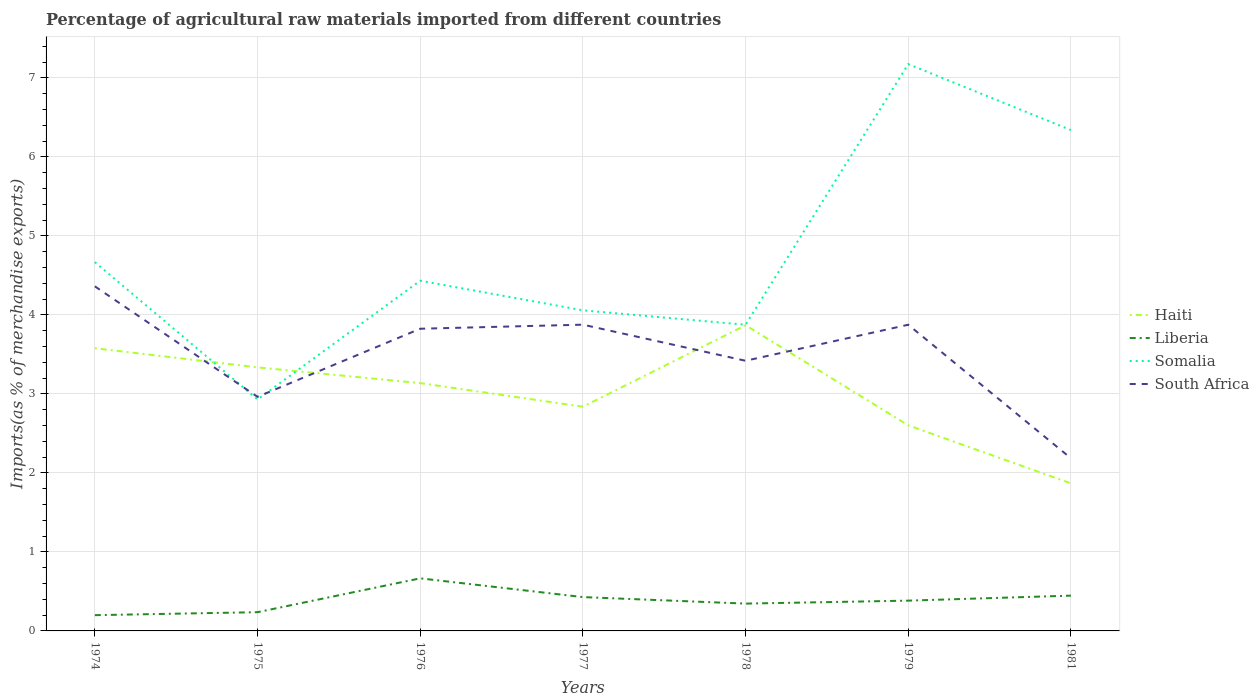How many different coloured lines are there?
Offer a very short reply. 4. Does the line corresponding to Somalia intersect with the line corresponding to Haiti?
Offer a very short reply. Yes. Across all years, what is the maximum percentage of imports to different countries in South Africa?
Make the answer very short. 2.19. In which year was the percentage of imports to different countries in Somalia maximum?
Your answer should be compact. 1975. What is the total percentage of imports to different countries in South Africa in the graph?
Your response must be concise. 1.64. What is the difference between the highest and the second highest percentage of imports to different countries in South Africa?
Make the answer very short. 2.18. Is the percentage of imports to different countries in Haiti strictly greater than the percentage of imports to different countries in Somalia over the years?
Your answer should be compact. No. How many lines are there?
Ensure brevity in your answer.  4. What is the difference between two consecutive major ticks on the Y-axis?
Provide a short and direct response. 1. Does the graph contain any zero values?
Your response must be concise. No. Does the graph contain grids?
Keep it short and to the point. Yes. Where does the legend appear in the graph?
Your response must be concise. Center right. What is the title of the graph?
Provide a succinct answer. Percentage of agricultural raw materials imported from different countries. What is the label or title of the Y-axis?
Give a very brief answer. Imports(as % of merchandise exports). What is the Imports(as % of merchandise exports) of Haiti in 1974?
Give a very brief answer. 3.58. What is the Imports(as % of merchandise exports) in Liberia in 1974?
Keep it short and to the point. 0.2. What is the Imports(as % of merchandise exports) of Somalia in 1974?
Offer a very short reply. 4.67. What is the Imports(as % of merchandise exports) in South Africa in 1974?
Provide a short and direct response. 4.36. What is the Imports(as % of merchandise exports) in Haiti in 1975?
Keep it short and to the point. 3.34. What is the Imports(as % of merchandise exports) in Liberia in 1975?
Your answer should be compact. 0.24. What is the Imports(as % of merchandise exports) of Somalia in 1975?
Your answer should be compact. 2.93. What is the Imports(as % of merchandise exports) in South Africa in 1975?
Offer a very short reply. 2.96. What is the Imports(as % of merchandise exports) of Haiti in 1976?
Keep it short and to the point. 3.14. What is the Imports(as % of merchandise exports) of Liberia in 1976?
Give a very brief answer. 0.67. What is the Imports(as % of merchandise exports) of Somalia in 1976?
Make the answer very short. 4.43. What is the Imports(as % of merchandise exports) in South Africa in 1976?
Provide a short and direct response. 3.82. What is the Imports(as % of merchandise exports) of Haiti in 1977?
Provide a succinct answer. 2.84. What is the Imports(as % of merchandise exports) in Liberia in 1977?
Make the answer very short. 0.43. What is the Imports(as % of merchandise exports) in Somalia in 1977?
Make the answer very short. 4.06. What is the Imports(as % of merchandise exports) in South Africa in 1977?
Provide a succinct answer. 3.88. What is the Imports(as % of merchandise exports) of Haiti in 1978?
Make the answer very short. 3.87. What is the Imports(as % of merchandise exports) in Liberia in 1978?
Your answer should be very brief. 0.35. What is the Imports(as % of merchandise exports) of Somalia in 1978?
Make the answer very short. 3.88. What is the Imports(as % of merchandise exports) in South Africa in 1978?
Your answer should be very brief. 3.42. What is the Imports(as % of merchandise exports) of Haiti in 1979?
Your answer should be very brief. 2.6. What is the Imports(as % of merchandise exports) of Liberia in 1979?
Provide a short and direct response. 0.38. What is the Imports(as % of merchandise exports) in Somalia in 1979?
Provide a short and direct response. 7.17. What is the Imports(as % of merchandise exports) in South Africa in 1979?
Offer a terse response. 3.88. What is the Imports(as % of merchandise exports) in Haiti in 1981?
Offer a terse response. 1.87. What is the Imports(as % of merchandise exports) of Liberia in 1981?
Offer a very short reply. 0.45. What is the Imports(as % of merchandise exports) in Somalia in 1981?
Your answer should be compact. 6.34. What is the Imports(as % of merchandise exports) in South Africa in 1981?
Keep it short and to the point. 2.19. Across all years, what is the maximum Imports(as % of merchandise exports) in Haiti?
Offer a very short reply. 3.87. Across all years, what is the maximum Imports(as % of merchandise exports) of Liberia?
Keep it short and to the point. 0.67. Across all years, what is the maximum Imports(as % of merchandise exports) of Somalia?
Provide a succinct answer. 7.17. Across all years, what is the maximum Imports(as % of merchandise exports) in South Africa?
Make the answer very short. 4.36. Across all years, what is the minimum Imports(as % of merchandise exports) in Haiti?
Provide a succinct answer. 1.87. Across all years, what is the minimum Imports(as % of merchandise exports) of Liberia?
Give a very brief answer. 0.2. Across all years, what is the minimum Imports(as % of merchandise exports) of Somalia?
Your answer should be compact. 2.93. Across all years, what is the minimum Imports(as % of merchandise exports) of South Africa?
Ensure brevity in your answer.  2.19. What is the total Imports(as % of merchandise exports) of Haiti in the graph?
Offer a terse response. 21.23. What is the total Imports(as % of merchandise exports) in Liberia in the graph?
Offer a terse response. 2.71. What is the total Imports(as % of merchandise exports) of Somalia in the graph?
Make the answer very short. 33.48. What is the total Imports(as % of merchandise exports) of South Africa in the graph?
Ensure brevity in your answer.  24.51. What is the difference between the Imports(as % of merchandise exports) of Haiti in 1974 and that in 1975?
Offer a terse response. 0.24. What is the difference between the Imports(as % of merchandise exports) in Liberia in 1974 and that in 1975?
Your response must be concise. -0.04. What is the difference between the Imports(as % of merchandise exports) of Somalia in 1974 and that in 1975?
Your response must be concise. 1.74. What is the difference between the Imports(as % of merchandise exports) in South Africa in 1974 and that in 1975?
Ensure brevity in your answer.  1.4. What is the difference between the Imports(as % of merchandise exports) of Haiti in 1974 and that in 1976?
Give a very brief answer. 0.44. What is the difference between the Imports(as % of merchandise exports) of Liberia in 1974 and that in 1976?
Your answer should be very brief. -0.47. What is the difference between the Imports(as % of merchandise exports) in Somalia in 1974 and that in 1976?
Keep it short and to the point. 0.24. What is the difference between the Imports(as % of merchandise exports) in South Africa in 1974 and that in 1976?
Provide a succinct answer. 0.54. What is the difference between the Imports(as % of merchandise exports) in Haiti in 1974 and that in 1977?
Make the answer very short. 0.74. What is the difference between the Imports(as % of merchandise exports) of Liberia in 1974 and that in 1977?
Your response must be concise. -0.23. What is the difference between the Imports(as % of merchandise exports) in Somalia in 1974 and that in 1977?
Your response must be concise. 0.61. What is the difference between the Imports(as % of merchandise exports) of South Africa in 1974 and that in 1977?
Your answer should be compact. 0.49. What is the difference between the Imports(as % of merchandise exports) in Haiti in 1974 and that in 1978?
Keep it short and to the point. -0.29. What is the difference between the Imports(as % of merchandise exports) in Liberia in 1974 and that in 1978?
Ensure brevity in your answer.  -0.15. What is the difference between the Imports(as % of merchandise exports) in Somalia in 1974 and that in 1978?
Provide a short and direct response. 0.79. What is the difference between the Imports(as % of merchandise exports) of South Africa in 1974 and that in 1978?
Give a very brief answer. 0.94. What is the difference between the Imports(as % of merchandise exports) in Haiti in 1974 and that in 1979?
Offer a terse response. 0.98. What is the difference between the Imports(as % of merchandise exports) of Liberia in 1974 and that in 1979?
Your answer should be compact. -0.18. What is the difference between the Imports(as % of merchandise exports) of Somalia in 1974 and that in 1979?
Your answer should be compact. -2.51. What is the difference between the Imports(as % of merchandise exports) in South Africa in 1974 and that in 1979?
Your response must be concise. 0.49. What is the difference between the Imports(as % of merchandise exports) in Haiti in 1974 and that in 1981?
Ensure brevity in your answer.  1.71. What is the difference between the Imports(as % of merchandise exports) in Liberia in 1974 and that in 1981?
Provide a short and direct response. -0.25. What is the difference between the Imports(as % of merchandise exports) of Somalia in 1974 and that in 1981?
Provide a short and direct response. -1.67. What is the difference between the Imports(as % of merchandise exports) of South Africa in 1974 and that in 1981?
Give a very brief answer. 2.18. What is the difference between the Imports(as % of merchandise exports) of Haiti in 1975 and that in 1976?
Offer a very short reply. 0.2. What is the difference between the Imports(as % of merchandise exports) of Liberia in 1975 and that in 1976?
Provide a succinct answer. -0.43. What is the difference between the Imports(as % of merchandise exports) of Somalia in 1975 and that in 1976?
Provide a short and direct response. -1.5. What is the difference between the Imports(as % of merchandise exports) in South Africa in 1975 and that in 1976?
Keep it short and to the point. -0.86. What is the difference between the Imports(as % of merchandise exports) in Haiti in 1975 and that in 1977?
Make the answer very short. 0.5. What is the difference between the Imports(as % of merchandise exports) of Liberia in 1975 and that in 1977?
Your answer should be compact. -0.19. What is the difference between the Imports(as % of merchandise exports) of Somalia in 1975 and that in 1977?
Ensure brevity in your answer.  -1.13. What is the difference between the Imports(as % of merchandise exports) of South Africa in 1975 and that in 1977?
Your response must be concise. -0.91. What is the difference between the Imports(as % of merchandise exports) of Haiti in 1975 and that in 1978?
Provide a succinct answer. -0.53. What is the difference between the Imports(as % of merchandise exports) in Liberia in 1975 and that in 1978?
Provide a short and direct response. -0.11. What is the difference between the Imports(as % of merchandise exports) of Somalia in 1975 and that in 1978?
Give a very brief answer. -0.95. What is the difference between the Imports(as % of merchandise exports) of South Africa in 1975 and that in 1978?
Provide a succinct answer. -0.46. What is the difference between the Imports(as % of merchandise exports) in Haiti in 1975 and that in 1979?
Keep it short and to the point. 0.73. What is the difference between the Imports(as % of merchandise exports) in Liberia in 1975 and that in 1979?
Your answer should be compact. -0.15. What is the difference between the Imports(as % of merchandise exports) in Somalia in 1975 and that in 1979?
Your answer should be very brief. -4.24. What is the difference between the Imports(as % of merchandise exports) in South Africa in 1975 and that in 1979?
Offer a terse response. -0.91. What is the difference between the Imports(as % of merchandise exports) in Haiti in 1975 and that in 1981?
Ensure brevity in your answer.  1.47. What is the difference between the Imports(as % of merchandise exports) in Liberia in 1975 and that in 1981?
Provide a succinct answer. -0.21. What is the difference between the Imports(as % of merchandise exports) in Somalia in 1975 and that in 1981?
Your answer should be compact. -3.41. What is the difference between the Imports(as % of merchandise exports) in South Africa in 1975 and that in 1981?
Provide a succinct answer. 0.78. What is the difference between the Imports(as % of merchandise exports) in Haiti in 1976 and that in 1977?
Provide a short and direct response. 0.3. What is the difference between the Imports(as % of merchandise exports) of Liberia in 1976 and that in 1977?
Offer a terse response. 0.24. What is the difference between the Imports(as % of merchandise exports) of Somalia in 1976 and that in 1977?
Your answer should be compact. 0.37. What is the difference between the Imports(as % of merchandise exports) in South Africa in 1976 and that in 1977?
Make the answer very short. -0.05. What is the difference between the Imports(as % of merchandise exports) of Haiti in 1976 and that in 1978?
Provide a succinct answer. -0.73. What is the difference between the Imports(as % of merchandise exports) of Liberia in 1976 and that in 1978?
Ensure brevity in your answer.  0.32. What is the difference between the Imports(as % of merchandise exports) of Somalia in 1976 and that in 1978?
Your answer should be very brief. 0.56. What is the difference between the Imports(as % of merchandise exports) of South Africa in 1976 and that in 1978?
Give a very brief answer. 0.41. What is the difference between the Imports(as % of merchandise exports) in Haiti in 1976 and that in 1979?
Offer a very short reply. 0.53. What is the difference between the Imports(as % of merchandise exports) of Liberia in 1976 and that in 1979?
Provide a short and direct response. 0.28. What is the difference between the Imports(as % of merchandise exports) in Somalia in 1976 and that in 1979?
Offer a terse response. -2.74. What is the difference between the Imports(as % of merchandise exports) of South Africa in 1976 and that in 1979?
Provide a succinct answer. -0.05. What is the difference between the Imports(as % of merchandise exports) of Haiti in 1976 and that in 1981?
Provide a succinct answer. 1.27. What is the difference between the Imports(as % of merchandise exports) in Liberia in 1976 and that in 1981?
Provide a short and direct response. 0.22. What is the difference between the Imports(as % of merchandise exports) in Somalia in 1976 and that in 1981?
Your answer should be very brief. -1.91. What is the difference between the Imports(as % of merchandise exports) in South Africa in 1976 and that in 1981?
Your response must be concise. 1.64. What is the difference between the Imports(as % of merchandise exports) of Haiti in 1977 and that in 1978?
Keep it short and to the point. -1.03. What is the difference between the Imports(as % of merchandise exports) of Liberia in 1977 and that in 1978?
Make the answer very short. 0.08. What is the difference between the Imports(as % of merchandise exports) of Somalia in 1977 and that in 1978?
Offer a terse response. 0.18. What is the difference between the Imports(as % of merchandise exports) in South Africa in 1977 and that in 1978?
Give a very brief answer. 0.46. What is the difference between the Imports(as % of merchandise exports) of Haiti in 1977 and that in 1979?
Your answer should be compact. 0.24. What is the difference between the Imports(as % of merchandise exports) in Liberia in 1977 and that in 1979?
Make the answer very short. 0.04. What is the difference between the Imports(as % of merchandise exports) of Somalia in 1977 and that in 1979?
Give a very brief answer. -3.12. What is the difference between the Imports(as % of merchandise exports) in South Africa in 1977 and that in 1979?
Ensure brevity in your answer.  0. What is the difference between the Imports(as % of merchandise exports) of Haiti in 1977 and that in 1981?
Offer a very short reply. 0.97. What is the difference between the Imports(as % of merchandise exports) in Liberia in 1977 and that in 1981?
Give a very brief answer. -0.02. What is the difference between the Imports(as % of merchandise exports) in Somalia in 1977 and that in 1981?
Your answer should be very brief. -2.28. What is the difference between the Imports(as % of merchandise exports) in South Africa in 1977 and that in 1981?
Your response must be concise. 1.69. What is the difference between the Imports(as % of merchandise exports) of Haiti in 1978 and that in 1979?
Keep it short and to the point. 1.27. What is the difference between the Imports(as % of merchandise exports) of Liberia in 1978 and that in 1979?
Ensure brevity in your answer.  -0.04. What is the difference between the Imports(as % of merchandise exports) of Somalia in 1978 and that in 1979?
Keep it short and to the point. -3.3. What is the difference between the Imports(as % of merchandise exports) of South Africa in 1978 and that in 1979?
Give a very brief answer. -0.46. What is the difference between the Imports(as % of merchandise exports) in Haiti in 1978 and that in 1981?
Make the answer very short. 2. What is the difference between the Imports(as % of merchandise exports) of Liberia in 1978 and that in 1981?
Your response must be concise. -0.1. What is the difference between the Imports(as % of merchandise exports) of Somalia in 1978 and that in 1981?
Your answer should be compact. -2.46. What is the difference between the Imports(as % of merchandise exports) in South Africa in 1978 and that in 1981?
Your response must be concise. 1.23. What is the difference between the Imports(as % of merchandise exports) in Haiti in 1979 and that in 1981?
Offer a terse response. 0.73. What is the difference between the Imports(as % of merchandise exports) of Liberia in 1979 and that in 1981?
Keep it short and to the point. -0.06. What is the difference between the Imports(as % of merchandise exports) of Somalia in 1979 and that in 1981?
Your response must be concise. 0.83. What is the difference between the Imports(as % of merchandise exports) in South Africa in 1979 and that in 1981?
Ensure brevity in your answer.  1.69. What is the difference between the Imports(as % of merchandise exports) in Haiti in 1974 and the Imports(as % of merchandise exports) in Liberia in 1975?
Ensure brevity in your answer.  3.34. What is the difference between the Imports(as % of merchandise exports) in Haiti in 1974 and the Imports(as % of merchandise exports) in Somalia in 1975?
Your answer should be very brief. 0.65. What is the difference between the Imports(as % of merchandise exports) in Haiti in 1974 and the Imports(as % of merchandise exports) in South Africa in 1975?
Your answer should be compact. 0.61. What is the difference between the Imports(as % of merchandise exports) of Liberia in 1974 and the Imports(as % of merchandise exports) of Somalia in 1975?
Provide a short and direct response. -2.73. What is the difference between the Imports(as % of merchandise exports) of Liberia in 1974 and the Imports(as % of merchandise exports) of South Africa in 1975?
Offer a terse response. -2.76. What is the difference between the Imports(as % of merchandise exports) in Somalia in 1974 and the Imports(as % of merchandise exports) in South Africa in 1975?
Ensure brevity in your answer.  1.71. What is the difference between the Imports(as % of merchandise exports) in Haiti in 1974 and the Imports(as % of merchandise exports) in Liberia in 1976?
Your answer should be very brief. 2.91. What is the difference between the Imports(as % of merchandise exports) in Haiti in 1974 and the Imports(as % of merchandise exports) in Somalia in 1976?
Provide a short and direct response. -0.85. What is the difference between the Imports(as % of merchandise exports) of Haiti in 1974 and the Imports(as % of merchandise exports) of South Africa in 1976?
Make the answer very short. -0.25. What is the difference between the Imports(as % of merchandise exports) in Liberia in 1974 and the Imports(as % of merchandise exports) in Somalia in 1976?
Provide a succinct answer. -4.23. What is the difference between the Imports(as % of merchandise exports) in Liberia in 1974 and the Imports(as % of merchandise exports) in South Africa in 1976?
Keep it short and to the point. -3.63. What is the difference between the Imports(as % of merchandise exports) of Somalia in 1974 and the Imports(as % of merchandise exports) of South Africa in 1976?
Provide a short and direct response. 0.84. What is the difference between the Imports(as % of merchandise exports) of Haiti in 1974 and the Imports(as % of merchandise exports) of Liberia in 1977?
Offer a very short reply. 3.15. What is the difference between the Imports(as % of merchandise exports) of Haiti in 1974 and the Imports(as % of merchandise exports) of Somalia in 1977?
Your answer should be compact. -0.48. What is the difference between the Imports(as % of merchandise exports) of Haiti in 1974 and the Imports(as % of merchandise exports) of South Africa in 1977?
Ensure brevity in your answer.  -0.3. What is the difference between the Imports(as % of merchandise exports) of Liberia in 1974 and the Imports(as % of merchandise exports) of Somalia in 1977?
Offer a terse response. -3.86. What is the difference between the Imports(as % of merchandise exports) of Liberia in 1974 and the Imports(as % of merchandise exports) of South Africa in 1977?
Make the answer very short. -3.68. What is the difference between the Imports(as % of merchandise exports) in Somalia in 1974 and the Imports(as % of merchandise exports) in South Africa in 1977?
Ensure brevity in your answer.  0.79. What is the difference between the Imports(as % of merchandise exports) in Haiti in 1974 and the Imports(as % of merchandise exports) in Liberia in 1978?
Your answer should be compact. 3.23. What is the difference between the Imports(as % of merchandise exports) of Haiti in 1974 and the Imports(as % of merchandise exports) of Somalia in 1978?
Keep it short and to the point. -0.3. What is the difference between the Imports(as % of merchandise exports) in Haiti in 1974 and the Imports(as % of merchandise exports) in South Africa in 1978?
Your response must be concise. 0.16. What is the difference between the Imports(as % of merchandise exports) in Liberia in 1974 and the Imports(as % of merchandise exports) in Somalia in 1978?
Your response must be concise. -3.68. What is the difference between the Imports(as % of merchandise exports) of Liberia in 1974 and the Imports(as % of merchandise exports) of South Africa in 1978?
Your answer should be compact. -3.22. What is the difference between the Imports(as % of merchandise exports) of Somalia in 1974 and the Imports(as % of merchandise exports) of South Africa in 1978?
Your response must be concise. 1.25. What is the difference between the Imports(as % of merchandise exports) of Haiti in 1974 and the Imports(as % of merchandise exports) of Liberia in 1979?
Your answer should be compact. 3.19. What is the difference between the Imports(as % of merchandise exports) in Haiti in 1974 and the Imports(as % of merchandise exports) in Somalia in 1979?
Your answer should be compact. -3.6. What is the difference between the Imports(as % of merchandise exports) of Haiti in 1974 and the Imports(as % of merchandise exports) of South Africa in 1979?
Provide a succinct answer. -0.3. What is the difference between the Imports(as % of merchandise exports) of Liberia in 1974 and the Imports(as % of merchandise exports) of Somalia in 1979?
Offer a very short reply. -6.97. What is the difference between the Imports(as % of merchandise exports) of Liberia in 1974 and the Imports(as % of merchandise exports) of South Africa in 1979?
Offer a very short reply. -3.68. What is the difference between the Imports(as % of merchandise exports) of Somalia in 1974 and the Imports(as % of merchandise exports) of South Africa in 1979?
Offer a very short reply. 0.79. What is the difference between the Imports(as % of merchandise exports) of Haiti in 1974 and the Imports(as % of merchandise exports) of Liberia in 1981?
Keep it short and to the point. 3.13. What is the difference between the Imports(as % of merchandise exports) in Haiti in 1974 and the Imports(as % of merchandise exports) in Somalia in 1981?
Provide a succinct answer. -2.76. What is the difference between the Imports(as % of merchandise exports) in Haiti in 1974 and the Imports(as % of merchandise exports) in South Africa in 1981?
Give a very brief answer. 1.39. What is the difference between the Imports(as % of merchandise exports) in Liberia in 1974 and the Imports(as % of merchandise exports) in Somalia in 1981?
Ensure brevity in your answer.  -6.14. What is the difference between the Imports(as % of merchandise exports) of Liberia in 1974 and the Imports(as % of merchandise exports) of South Africa in 1981?
Your answer should be very brief. -1.99. What is the difference between the Imports(as % of merchandise exports) of Somalia in 1974 and the Imports(as % of merchandise exports) of South Africa in 1981?
Provide a short and direct response. 2.48. What is the difference between the Imports(as % of merchandise exports) in Haiti in 1975 and the Imports(as % of merchandise exports) in Liberia in 1976?
Keep it short and to the point. 2.67. What is the difference between the Imports(as % of merchandise exports) of Haiti in 1975 and the Imports(as % of merchandise exports) of Somalia in 1976?
Give a very brief answer. -1.1. What is the difference between the Imports(as % of merchandise exports) in Haiti in 1975 and the Imports(as % of merchandise exports) in South Africa in 1976?
Your answer should be compact. -0.49. What is the difference between the Imports(as % of merchandise exports) in Liberia in 1975 and the Imports(as % of merchandise exports) in Somalia in 1976?
Offer a terse response. -4.2. What is the difference between the Imports(as % of merchandise exports) in Liberia in 1975 and the Imports(as % of merchandise exports) in South Africa in 1976?
Provide a short and direct response. -3.59. What is the difference between the Imports(as % of merchandise exports) of Somalia in 1975 and the Imports(as % of merchandise exports) of South Africa in 1976?
Offer a very short reply. -0.9. What is the difference between the Imports(as % of merchandise exports) of Haiti in 1975 and the Imports(as % of merchandise exports) of Liberia in 1977?
Your response must be concise. 2.91. What is the difference between the Imports(as % of merchandise exports) in Haiti in 1975 and the Imports(as % of merchandise exports) in Somalia in 1977?
Offer a very short reply. -0.72. What is the difference between the Imports(as % of merchandise exports) in Haiti in 1975 and the Imports(as % of merchandise exports) in South Africa in 1977?
Give a very brief answer. -0.54. What is the difference between the Imports(as % of merchandise exports) of Liberia in 1975 and the Imports(as % of merchandise exports) of Somalia in 1977?
Provide a succinct answer. -3.82. What is the difference between the Imports(as % of merchandise exports) of Liberia in 1975 and the Imports(as % of merchandise exports) of South Africa in 1977?
Provide a short and direct response. -3.64. What is the difference between the Imports(as % of merchandise exports) of Somalia in 1975 and the Imports(as % of merchandise exports) of South Africa in 1977?
Provide a short and direct response. -0.95. What is the difference between the Imports(as % of merchandise exports) of Haiti in 1975 and the Imports(as % of merchandise exports) of Liberia in 1978?
Provide a succinct answer. 2.99. What is the difference between the Imports(as % of merchandise exports) in Haiti in 1975 and the Imports(as % of merchandise exports) in Somalia in 1978?
Ensure brevity in your answer.  -0.54. What is the difference between the Imports(as % of merchandise exports) in Haiti in 1975 and the Imports(as % of merchandise exports) in South Africa in 1978?
Provide a short and direct response. -0.08. What is the difference between the Imports(as % of merchandise exports) of Liberia in 1975 and the Imports(as % of merchandise exports) of Somalia in 1978?
Your response must be concise. -3.64. What is the difference between the Imports(as % of merchandise exports) in Liberia in 1975 and the Imports(as % of merchandise exports) in South Africa in 1978?
Your answer should be compact. -3.18. What is the difference between the Imports(as % of merchandise exports) in Somalia in 1975 and the Imports(as % of merchandise exports) in South Africa in 1978?
Offer a very short reply. -0.49. What is the difference between the Imports(as % of merchandise exports) in Haiti in 1975 and the Imports(as % of merchandise exports) in Liberia in 1979?
Make the answer very short. 2.95. What is the difference between the Imports(as % of merchandise exports) in Haiti in 1975 and the Imports(as % of merchandise exports) in Somalia in 1979?
Offer a terse response. -3.84. What is the difference between the Imports(as % of merchandise exports) of Haiti in 1975 and the Imports(as % of merchandise exports) of South Africa in 1979?
Offer a terse response. -0.54. What is the difference between the Imports(as % of merchandise exports) of Liberia in 1975 and the Imports(as % of merchandise exports) of Somalia in 1979?
Ensure brevity in your answer.  -6.94. What is the difference between the Imports(as % of merchandise exports) of Liberia in 1975 and the Imports(as % of merchandise exports) of South Africa in 1979?
Offer a terse response. -3.64. What is the difference between the Imports(as % of merchandise exports) in Somalia in 1975 and the Imports(as % of merchandise exports) in South Africa in 1979?
Your answer should be compact. -0.95. What is the difference between the Imports(as % of merchandise exports) of Haiti in 1975 and the Imports(as % of merchandise exports) of Liberia in 1981?
Your response must be concise. 2.89. What is the difference between the Imports(as % of merchandise exports) of Haiti in 1975 and the Imports(as % of merchandise exports) of Somalia in 1981?
Keep it short and to the point. -3. What is the difference between the Imports(as % of merchandise exports) of Haiti in 1975 and the Imports(as % of merchandise exports) of South Africa in 1981?
Provide a short and direct response. 1.15. What is the difference between the Imports(as % of merchandise exports) of Liberia in 1975 and the Imports(as % of merchandise exports) of Somalia in 1981?
Your response must be concise. -6.1. What is the difference between the Imports(as % of merchandise exports) in Liberia in 1975 and the Imports(as % of merchandise exports) in South Africa in 1981?
Your answer should be very brief. -1.95. What is the difference between the Imports(as % of merchandise exports) in Somalia in 1975 and the Imports(as % of merchandise exports) in South Africa in 1981?
Keep it short and to the point. 0.74. What is the difference between the Imports(as % of merchandise exports) of Haiti in 1976 and the Imports(as % of merchandise exports) of Liberia in 1977?
Give a very brief answer. 2.71. What is the difference between the Imports(as % of merchandise exports) in Haiti in 1976 and the Imports(as % of merchandise exports) in Somalia in 1977?
Give a very brief answer. -0.92. What is the difference between the Imports(as % of merchandise exports) of Haiti in 1976 and the Imports(as % of merchandise exports) of South Africa in 1977?
Provide a short and direct response. -0.74. What is the difference between the Imports(as % of merchandise exports) of Liberia in 1976 and the Imports(as % of merchandise exports) of Somalia in 1977?
Ensure brevity in your answer.  -3.39. What is the difference between the Imports(as % of merchandise exports) of Liberia in 1976 and the Imports(as % of merchandise exports) of South Africa in 1977?
Ensure brevity in your answer.  -3.21. What is the difference between the Imports(as % of merchandise exports) in Somalia in 1976 and the Imports(as % of merchandise exports) in South Africa in 1977?
Provide a short and direct response. 0.56. What is the difference between the Imports(as % of merchandise exports) in Haiti in 1976 and the Imports(as % of merchandise exports) in Liberia in 1978?
Provide a short and direct response. 2.79. What is the difference between the Imports(as % of merchandise exports) in Haiti in 1976 and the Imports(as % of merchandise exports) in Somalia in 1978?
Ensure brevity in your answer.  -0.74. What is the difference between the Imports(as % of merchandise exports) in Haiti in 1976 and the Imports(as % of merchandise exports) in South Africa in 1978?
Ensure brevity in your answer.  -0.28. What is the difference between the Imports(as % of merchandise exports) in Liberia in 1976 and the Imports(as % of merchandise exports) in Somalia in 1978?
Provide a short and direct response. -3.21. What is the difference between the Imports(as % of merchandise exports) of Liberia in 1976 and the Imports(as % of merchandise exports) of South Africa in 1978?
Offer a very short reply. -2.75. What is the difference between the Imports(as % of merchandise exports) in Somalia in 1976 and the Imports(as % of merchandise exports) in South Africa in 1978?
Ensure brevity in your answer.  1.01. What is the difference between the Imports(as % of merchandise exports) of Haiti in 1976 and the Imports(as % of merchandise exports) of Liberia in 1979?
Keep it short and to the point. 2.75. What is the difference between the Imports(as % of merchandise exports) in Haiti in 1976 and the Imports(as % of merchandise exports) in Somalia in 1979?
Provide a short and direct response. -4.04. What is the difference between the Imports(as % of merchandise exports) of Haiti in 1976 and the Imports(as % of merchandise exports) of South Africa in 1979?
Keep it short and to the point. -0.74. What is the difference between the Imports(as % of merchandise exports) in Liberia in 1976 and the Imports(as % of merchandise exports) in Somalia in 1979?
Provide a succinct answer. -6.51. What is the difference between the Imports(as % of merchandise exports) of Liberia in 1976 and the Imports(as % of merchandise exports) of South Africa in 1979?
Your answer should be compact. -3.21. What is the difference between the Imports(as % of merchandise exports) of Somalia in 1976 and the Imports(as % of merchandise exports) of South Africa in 1979?
Offer a very short reply. 0.56. What is the difference between the Imports(as % of merchandise exports) of Haiti in 1976 and the Imports(as % of merchandise exports) of Liberia in 1981?
Your answer should be very brief. 2.69. What is the difference between the Imports(as % of merchandise exports) of Haiti in 1976 and the Imports(as % of merchandise exports) of Somalia in 1981?
Your answer should be compact. -3.2. What is the difference between the Imports(as % of merchandise exports) in Haiti in 1976 and the Imports(as % of merchandise exports) in South Africa in 1981?
Offer a terse response. 0.95. What is the difference between the Imports(as % of merchandise exports) in Liberia in 1976 and the Imports(as % of merchandise exports) in Somalia in 1981?
Make the answer very short. -5.67. What is the difference between the Imports(as % of merchandise exports) in Liberia in 1976 and the Imports(as % of merchandise exports) in South Africa in 1981?
Your answer should be compact. -1.52. What is the difference between the Imports(as % of merchandise exports) in Somalia in 1976 and the Imports(as % of merchandise exports) in South Africa in 1981?
Your response must be concise. 2.25. What is the difference between the Imports(as % of merchandise exports) of Haiti in 1977 and the Imports(as % of merchandise exports) of Liberia in 1978?
Ensure brevity in your answer.  2.49. What is the difference between the Imports(as % of merchandise exports) of Haiti in 1977 and the Imports(as % of merchandise exports) of Somalia in 1978?
Provide a short and direct response. -1.04. What is the difference between the Imports(as % of merchandise exports) of Haiti in 1977 and the Imports(as % of merchandise exports) of South Africa in 1978?
Give a very brief answer. -0.58. What is the difference between the Imports(as % of merchandise exports) in Liberia in 1977 and the Imports(as % of merchandise exports) in Somalia in 1978?
Provide a short and direct response. -3.45. What is the difference between the Imports(as % of merchandise exports) in Liberia in 1977 and the Imports(as % of merchandise exports) in South Africa in 1978?
Provide a short and direct response. -2.99. What is the difference between the Imports(as % of merchandise exports) of Somalia in 1977 and the Imports(as % of merchandise exports) of South Africa in 1978?
Your response must be concise. 0.64. What is the difference between the Imports(as % of merchandise exports) of Haiti in 1977 and the Imports(as % of merchandise exports) of Liberia in 1979?
Ensure brevity in your answer.  2.45. What is the difference between the Imports(as % of merchandise exports) of Haiti in 1977 and the Imports(as % of merchandise exports) of Somalia in 1979?
Your answer should be compact. -4.34. What is the difference between the Imports(as % of merchandise exports) of Haiti in 1977 and the Imports(as % of merchandise exports) of South Africa in 1979?
Your answer should be compact. -1.04. What is the difference between the Imports(as % of merchandise exports) in Liberia in 1977 and the Imports(as % of merchandise exports) in Somalia in 1979?
Your answer should be very brief. -6.75. What is the difference between the Imports(as % of merchandise exports) in Liberia in 1977 and the Imports(as % of merchandise exports) in South Africa in 1979?
Your answer should be compact. -3.45. What is the difference between the Imports(as % of merchandise exports) of Somalia in 1977 and the Imports(as % of merchandise exports) of South Africa in 1979?
Offer a terse response. 0.18. What is the difference between the Imports(as % of merchandise exports) in Haiti in 1977 and the Imports(as % of merchandise exports) in Liberia in 1981?
Give a very brief answer. 2.39. What is the difference between the Imports(as % of merchandise exports) of Haiti in 1977 and the Imports(as % of merchandise exports) of Somalia in 1981?
Offer a very short reply. -3.5. What is the difference between the Imports(as % of merchandise exports) of Haiti in 1977 and the Imports(as % of merchandise exports) of South Africa in 1981?
Give a very brief answer. 0.65. What is the difference between the Imports(as % of merchandise exports) in Liberia in 1977 and the Imports(as % of merchandise exports) in Somalia in 1981?
Ensure brevity in your answer.  -5.91. What is the difference between the Imports(as % of merchandise exports) in Liberia in 1977 and the Imports(as % of merchandise exports) in South Africa in 1981?
Your answer should be compact. -1.76. What is the difference between the Imports(as % of merchandise exports) in Somalia in 1977 and the Imports(as % of merchandise exports) in South Africa in 1981?
Your answer should be compact. 1.87. What is the difference between the Imports(as % of merchandise exports) of Haiti in 1978 and the Imports(as % of merchandise exports) of Liberia in 1979?
Offer a very short reply. 3.49. What is the difference between the Imports(as % of merchandise exports) of Haiti in 1978 and the Imports(as % of merchandise exports) of Somalia in 1979?
Keep it short and to the point. -3.3. What is the difference between the Imports(as % of merchandise exports) in Haiti in 1978 and the Imports(as % of merchandise exports) in South Africa in 1979?
Provide a short and direct response. -0.01. What is the difference between the Imports(as % of merchandise exports) in Liberia in 1978 and the Imports(as % of merchandise exports) in Somalia in 1979?
Keep it short and to the point. -6.83. What is the difference between the Imports(as % of merchandise exports) of Liberia in 1978 and the Imports(as % of merchandise exports) of South Africa in 1979?
Offer a terse response. -3.53. What is the difference between the Imports(as % of merchandise exports) of Somalia in 1978 and the Imports(as % of merchandise exports) of South Africa in 1979?
Offer a terse response. -0. What is the difference between the Imports(as % of merchandise exports) in Haiti in 1978 and the Imports(as % of merchandise exports) in Liberia in 1981?
Ensure brevity in your answer.  3.42. What is the difference between the Imports(as % of merchandise exports) in Haiti in 1978 and the Imports(as % of merchandise exports) in Somalia in 1981?
Offer a very short reply. -2.47. What is the difference between the Imports(as % of merchandise exports) of Haiti in 1978 and the Imports(as % of merchandise exports) of South Africa in 1981?
Offer a very short reply. 1.68. What is the difference between the Imports(as % of merchandise exports) of Liberia in 1978 and the Imports(as % of merchandise exports) of Somalia in 1981?
Your answer should be very brief. -5.99. What is the difference between the Imports(as % of merchandise exports) of Liberia in 1978 and the Imports(as % of merchandise exports) of South Africa in 1981?
Make the answer very short. -1.84. What is the difference between the Imports(as % of merchandise exports) in Somalia in 1978 and the Imports(as % of merchandise exports) in South Africa in 1981?
Give a very brief answer. 1.69. What is the difference between the Imports(as % of merchandise exports) of Haiti in 1979 and the Imports(as % of merchandise exports) of Liberia in 1981?
Provide a short and direct response. 2.16. What is the difference between the Imports(as % of merchandise exports) of Haiti in 1979 and the Imports(as % of merchandise exports) of Somalia in 1981?
Ensure brevity in your answer.  -3.74. What is the difference between the Imports(as % of merchandise exports) in Haiti in 1979 and the Imports(as % of merchandise exports) in South Africa in 1981?
Make the answer very short. 0.42. What is the difference between the Imports(as % of merchandise exports) in Liberia in 1979 and the Imports(as % of merchandise exports) in Somalia in 1981?
Make the answer very short. -5.96. What is the difference between the Imports(as % of merchandise exports) of Liberia in 1979 and the Imports(as % of merchandise exports) of South Africa in 1981?
Your answer should be very brief. -1.8. What is the difference between the Imports(as % of merchandise exports) in Somalia in 1979 and the Imports(as % of merchandise exports) in South Africa in 1981?
Ensure brevity in your answer.  4.99. What is the average Imports(as % of merchandise exports) of Haiti per year?
Provide a short and direct response. 3.03. What is the average Imports(as % of merchandise exports) in Liberia per year?
Your answer should be very brief. 0.39. What is the average Imports(as % of merchandise exports) in Somalia per year?
Your response must be concise. 4.78. What is the average Imports(as % of merchandise exports) of South Africa per year?
Provide a succinct answer. 3.5. In the year 1974, what is the difference between the Imports(as % of merchandise exports) of Haiti and Imports(as % of merchandise exports) of Liberia?
Ensure brevity in your answer.  3.38. In the year 1974, what is the difference between the Imports(as % of merchandise exports) of Haiti and Imports(as % of merchandise exports) of Somalia?
Keep it short and to the point. -1.09. In the year 1974, what is the difference between the Imports(as % of merchandise exports) of Haiti and Imports(as % of merchandise exports) of South Africa?
Your answer should be compact. -0.78. In the year 1974, what is the difference between the Imports(as % of merchandise exports) in Liberia and Imports(as % of merchandise exports) in Somalia?
Keep it short and to the point. -4.47. In the year 1974, what is the difference between the Imports(as % of merchandise exports) of Liberia and Imports(as % of merchandise exports) of South Africa?
Offer a very short reply. -4.16. In the year 1974, what is the difference between the Imports(as % of merchandise exports) of Somalia and Imports(as % of merchandise exports) of South Africa?
Your response must be concise. 0.31. In the year 1975, what is the difference between the Imports(as % of merchandise exports) of Haiti and Imports(as % of merchandise exports) of Liberia?
Your response must be concise. 3.1. In the year 1975, what is the difference between the Imports(as % of merchandise exports) of Haiti and Imports(as % of merchandise exports) of Somalia?
Offer a terse response. 0.41. In the year 1975, what is the difference between the Imports(as % of merchandise exports) in Haiti and Imports(as % of merchandise exports) in South Africa?
Ensure brevity in your answer.  0.37. In the year 1975, what is the difference between the Imports(as % of merchandise exports) in Liberia and Imports(as % of merchandise exports) in Somalia?
Keep it short and to the point. -2.69. In the year 1975, what is the difference between the Imports(as % of merchandise exports) in Liberia and Imports(as % of merchandise exports) in South Africa?
Make the answer very short. -2.73. In the year 1975, what is the difference between the Imports(as % of merchandise exports) in Somalia and Imports(as % of merchandise exports) in South Africa?
Make the answer very short. -0.03. In the year 1976, what is the difference between the Imports(as % of merchandise exports) of Haiti and Imports(as % of merchandise exports) of Liberia?
Your response must be concise. 2.47. In the year 1976, what is the difference between the Imports(as % of merchandise exports) in Haiti and Imports(as % of merchandise exports) in Somalia?
Offer a terse response. -1.3. In the year 1976, what is the difference between the Imports(as % of merchandise exports) of Haiti and Imports(as % of merchandise exports) of South Africa?
Your response must be concise. -0.69. In the year 1976, what is the difference between the Imports(as % of merchandise exports) in Liberia and Imports(as % of merchandise exports) in Somalia?
Provide a short and direct response. -3.77. In the year 1976, what is the difference between the Imports(as % of merchandise exports) of Liberia and Imports(as % of merchandise exports) of South Africa?
Offer a very short reply. -3.16. In the year 1976, what is the difference between the Imports(as % of merchandise exports) in Somalia and Imports(as % of merchandise exports) in South Africa?
Offer a very short reply. 0.61. In the year 1977, what is the difference between the Imports(as % of merchandise exports) in Haiti and Imports(as % of merchandise exports) in Liberia?
Offer a terse response. 2.41. In the year 1977, what is the difference between the Imports(as % of merchandise exports) in Haiti and Imports(as % of merchandise exports) in Somalia?
Make the answer very short. -1.22. In the year 1977, what is the difference between the Imports(as % of merchandise exports) in Haiti and Imports(as % of merchandise exports) in South Africa?
Give a very brief answer. -1.04. In the year 1977, what is the difference between the Imports(as % of merchandise exports) of Liberia and Imports(as % of merchandise exports) of Somalia?
Provide a succinct answer. -3.63. In the year 1977, what is the difference between the Imports(as % of merchandise exports) in Liberia and Imports(as % of merchandise exports) in South Africa?
Ensure brevity in your answer.  -3.45. In the year 1977, what is the difference between the Imports(as % of merchandise exports) of Somalia and Imports(as % of merchandise exports) of South Africa?
Your response must be concise. 0.18. In the year 1978, what is the difference between the Imports(as % of merchandise exports) in Haiti and Imports(as % of merchandise exports) in Liberia?
Give a very brief answer. 3.52. In the year 1978, what is the difference between the Imports(as % of merchandise exports) in Haiti and Imports(as % of merchandise exports) in Somalia?
Make the answer very short. -0.01. In the year 1978, what is the difference between the Imports(as % of merchandise exports) in Haiti and Imports(as % of merchandise exports) in South Africa?
Offer a terse response. 0.45. In the year 1978, what is the difference between the Imports(as % of merchandise exports) in Liberia and Imports(as % of merchandise exports) in Somalia?
Your answer should be very brief. -3.53. In the year 1978, what is the difference between the Imports(as % of merchandise exports) of Liberia and Imports(as % of merchandise exports) of South Africa?
Give a very brief answer. -3.07. In the year 1978, what is the difference between the Imports(as % of merchandise exports) in Somalia and Imports(as % of merchandise exports) in South Africa?
Your response must be concise. 0.46. In the year 1979, what is the difference between the Imports(as % of merchandise exports) in Haiti and Imports(as % of merchandise exports) in Liberia?
Provide a succinct answer. 2.22. In the year 1979, what is the difference between the Imports(as % of merchandise exports) of Haiti and Imports(as % of merchandise exports) of Somalia?
Keep it short and to the point. -4.57. In the year 1979, what is the difference between the Imports(as % of merchandise exports) of Haiti and Imports(as % of merchandise exports) of South Africa?
Ensure brevity in your answer.  -1.27. In the year 1979, what is the difference between the Imports(as % of merchandise exports) in Liberia and Imports(as % of merchandise exports) in Somalia?
Your answer should be very brief. -6.79. In the year 1979, what is the difference between the Imports(as % of merchandise exports) in Liberia and Imports(as % of merchandise exports) in South Africa?
Keep it short and to the point. -3.49. In the year 1979, what is the difference between the Imports(as % of merchandise exports) of Somalia and Imports(as % of merchandise exports) of South Africa?
Offer a terse response. 3.3. In the year 1981, what is the difference between the Imports(as % of merchandise exports) of Haiti and Imports(as % of merchandise exports) of Liberia?
Make the answer very short. 1.42. In the year 1981, what is the difference between the Imports(as % of merchandise exports) in Haiti and Imports(as % of merchandise exports) in Somalia?
Provide a short and direct response. -4.47. In the year 1981, what is the difference between the Imports(as % of merchandise exports) of Haiti and Imports(as % of merchandise exports) of South Africa?
Give a very brief answer. -0.32. In the year 1981, what is the difference between the Imports(as % of merchandise exports) in Liberia and Imports(as % of merchandise exports) in Somalia?
Your response must be concise. -5.89. In the year 1981, what is the difference between the Imports(as % of merchandise exports) in Liberia and Imports(as % of merchandise exports) in South Africa?
Your answer should be compact. -1.74. In the year 1981, what is the difference between the Imports(as % of merchandise exports) in Somalia and Imports(as % of merchandise exports) in South Africa?
Provide a succinct answer. 4.15. What is the ratio of the Imports(as % of merchandise exports) in Haiti in 1974 to that in 1975?
Provide a succinct answer. 1.07. What is the ratio of the Imports(as % of merchandise exports) of Liberia in 1974 to that in 1975?
Make the answer very short. 0.84. What is the ratio of the Imports(as % of merchandise exports) in Somalia in 1974 to that in 1975?
Your response must be concise. 1.59. What is the ratio of the Imports(as % of merchandise exports) of South Africa in 1974 to that in 1975?
Your answer should be very brief. 1.47. What is the ratio of the Imports(as % of merchandise exports) of Haiti in 1974 to that in 1976?
Your answer should be very brief. 1.14. What is the ratio of the Imports(as % of merchandise exports) in Liberia in 1974 to that in 1976?
Your answer should be compact. 0.3. What is the ratio of the Imports(as % of merchandise exports) of Somalia in 1974 to that in 1976?
Offer a terse response. 1.05. What is the ratio of the Imports(as % of merchandise exports) of South Africa in 1974 to that in 1976?
Provide a succinct answer. 1.14. What is the ratio of the Imports(as % of merchandise exports) of Haiti in 1974 to that in 1977?
Offer a very short reply. 1.26. What is the ratio of the Imports(as % of merchandise exports) of Liberia in 1974 to that in 1977?
Your answer should be very brief. 0.47. What is the ratio of the Imports(as % of merchandise exports) of Somalia in 1974 to that in 1977?
Offer a very short reply. 1.15. What is the ratio of the Imports(as % of merchandise exports) in South Africa in 1974 to that in 1977?
Ensure brevity in your answer.  1.13. What is the ratio of the Imports(as % of merchandise exports) of Haiti in 1974 to that in 1978?
Offer a very short reply. 0.92. What is the ratio of the Imports(as % of merchandise exports) in Liberia in 1974 to that in 1978?
Your answer should be compact. 0.58. What is the ratio of the Imports(as % of merchandise exports) of Somalia in 1974 to that in 1978?
Make the answer very short. 1.2. What is the ratio of the Imports(as % of merchandise exports) of South Africa in 1974 to that in 1978?
Provide a short and direct response. 1.28. What is the ratio of the Imports(as % of merchandise exports) of Haiti in 1974 to that in 1979?
Keep it short and to the point. 1.38. What is the ratio of the Imports(as % of merchandise exports) in Liberia in 1974 to that in 1979?
Your answer should be compact. 0.52. What is the ratio of the Imports(as % of merchandise exports) in Somalia in 1974 to that in 1979?
Offer a very short reply. 0.65. What is the ratio of the Imports(as % of merchandise exports) in South Africa in 1974 to that in 1979?
Provide a short and direct response. 1.13. What is the ratio of the Imports(as % of merchandise exports) of Haiti in 1974 to that in 1981?
Ensure brevity in your answer.  1.92. What is the ratio of the Imports(as % of merchandise exports) of Liberia in 1974 to that in 1981?
Make the answer very short. 0.45. What is the ratio of the Imports(as % of merchandise exports) in Somalia in 1974 to that in 1981?
Keep it short and to the point. 0.74. What is the ratio of the Imports(as % of merchandise exports) in South Africa in 1974 to that in 1981?
Keep it short and to the point. 2. What is the ratio of the Imports(as % of merchandise exports) in Haiti in 1975 to that in 1976?
Your response must be concise. 1.06. What is the ratio of the Imports(as % of merchandise exports) of Liberia in 1975 to that in 1976?
Give a very brief answer. 0.36. What is the ratio of the Imports(as % of merchandise exports) of Somalia in 1975 to that in 1976?
Your answer should be compact. 0.66. What is the ratio of the Imports(as % of merchandise exports) in South Africa in 1975 to that in 1976?
Provide a succinct answer. 0.77. What is the ratio of the Imports(as % of merchandise exports) of Haiti in 1975 to that in 1977?
Provide a succinct answer. 1.18. What is the ratio of the Imports(as % of merchandise exports) of Liberia in 1975 to that in 1977?
Give a very brief answer. 0.55. What is the ratio of the Imports(as % of merchandise exports) in Somalia in 1975 to that in 1977?
Your answer should be very brief. 0.72. What is the ratio of the Imports(as % of merchandise exports) of South Africa in 1975 to that in 1977?
Your response must be concise. 0.76. What is the ratio of the Imports(as % of merchandise exports) of Haiti in 1975 to that in 1978?
Keep it short and to the point. 0.86. What is the ratio of the Imports(as % of merchandise exports) in Liberia in 1975 to that in 1978?
Provide a succinct answer. 0.69. What is the ratio of the Imports(as % of merchandise exports) in Somalia in 1975 to that in 1978?
Your answer should be compact. 0.76. What is the ratio of the Imports(as % of merchandise exports) of South Africa in 1975 to that in 1978?
Keep it short and to the point. 0.87. What is the ratio of the Imports(as % of merchandise exports) of Haiti in 1975 to that in 1979?
Your response must be concise. 1.28. What is the ratio of the Imports(as % of merchandise exports) in Liberia in 1975 to that in 1979?
Keep it short and to the point. 0.62. What is the ratio of the Imports(as % of merchandise exports) in Somalia in 1975 to that in 1979?
Your response must be concise. 0.41. What is the ratio of the Imports(as % of merchandise exports) in South Africa in 1975 to that in 1979?
Make the answer very short. 0.76. What is the ratio of the Imports(as % of merchandise exports) of Haiti in 1975 to that in 1981?
Provide a succinct answer. 1.79. What is the ratio of the Imports(as % of merchandise exports) in Liberia in 1975 to that in 1981?
Make the answer very short. 0.53. What is the ratio of the Imports(as % of merchandise exports) in Somalia in 1975 to that in 1981?
Offer a terse response. 0.46. What is the ratio of the Imports(as % of merchandise exports) in South Africa in 1975 to that in 1981?
Give a very brief answer. 1.36. What is the ratio of the Imports(as % of merchandise exports) in Haiti in 1976 to that in 1977?
Provide a short and direct response. 1.11. What is the ratio of the Imports(as % of merchandise exports) in Liberia in 1976 to that in 1977?
Keep it short and to the point. 1.55. What is the ratio of the Imports(as % of merchandise exports) of Somalia in 1976 to that in 1977?
Make the answer very short. 1.09. What is the ratio of the Imports(as % of merchandise exports) of South Africa in 1976 to that in 1977?
Your answer should be very brief. 0.99. What is the ratio of the Imports(as % of merchandise exports) of Haiti in 1976 to that in 1978?
Keep it short and to the point. 0.81. What is the ratio of the Imports(as % of merchandise exports) of Liberia in 1976 to that in 1978?
Offer a terse response. 1.92. What is the ratio of the Imports(as % of merchandise exports) of Somalia in 1976 to that in 1978?
Provide a short and direct response. 1.14. What is the ratio of the Imports(as % of merchandise exports) of South Africa in 1976 to that in 1978?
Give a very brief answer. 1.12. What is the ratio of the Imports(as % of merchandise exports) in Haiti in 1976 to that in 1979?
Provide a short and direct response. 1.21. What is the ratio of the Imports(as % of merchandise exports) in Liberia in 1976 to that in 1979?
Keep it short and to the point. 1.74. What is the ratio of the Imports(as % of merchandise exports) in Somalia in 1976 to that in 1979?
Offer a terse response. 0.62. What is the ratio of the Imports(as % of merchandise exports) in South Africa in 1976 to that in 1979?
Provide a short and direct response. 0.99. What is the ratio of the Imports(as % of merchandise exports) of Haiti in 1976 to that in 1981?
Offer a very short reply. 1.68. What is the ratio of the Imports(as % of merchandise exports) in Liberia in 1976 to that in 1981?
Your answer should be very brief. 1.49. What is the ratio of the Imports(as % of merchandise exports) of Somalia in 1976 to that in 1981?
Make the answer very short. 0.7. What is the ratio of the Imports(as % of merchandise exports) of South Africa in 1976 to that in 1981?
Provide a short and direct response. 1.75. What is the ratio of the Imports(as % of merchandise exports) in Haiti in 1977 to that in 1978?
Give a very brief answer. 0.73. What is the ratio of the Imports(as % of merchandise exports) in Liberia in 1977 to that in 1978?
Your response must be concise. 1.24. What is the ratio of the Imports(as % of merchandise exports) in Somalia in 1977 to that in 1978?
Ensure brevity in your answer.  1.05. What is the ratio of the Imports(as % of merchandise exports) of South Africa in 1977 to that in 1978?
Give a very brief answer. 1.13. What is the ratio of the Imports(as % of merchandise exports) of Haiti in 1977 to that in 1979?
Your response must be concise. 1.09. What is the ratio of the Imports(as % of merchandise exports) of Liberia in 1977 to that in 1979?
Offer a terse response. 1.12. What is the ratio of the Imports(as % of merchandise exports) of Somalia in 1977 to that in 1979?
Ensure brevity in your answer.  0.57. What is the ratio of the Imports(as % of merchandise exports) of South Africa in 1977 to that in 1979?
Give a very brief answer. 1. What is the ratio of the Imports(as % of merchandise exports) of Haiti in 1977 to that in 1981?
Provide a short and direct response. 1.52. What is the ratio of the Imports(as % of merchandise exports) of Liberia in 1977 to that in 1981?
Provide a short and direct response. 0.96. What is the ratio of the Imports(as % of merchandise exports) of Somalia in 1977 to that in 1981?
Your answer should be compact. 0.64. What is the ratio of the Imports(as % of merchandise exports) of South Africa in 1977 to that in 1981?
Make the answer very short. 1.77. What is the ratio of the Imports(as % of merchandise exports) in Haiti in 1978 to that in 1979?
Offer a very short reply. 1.49. What is the ratio of the Imports(as % of merchandise exports) in Liberia in 1978 to that in 1979?
Offer a terse response. 0.9. What is the ratio of the Imports(as % of merchandise exports) of Somalia in 1978 to that in 1979?
Ensure brevity in your answer.  0.54. What is the ratio of the Imports(as % of merchandise exports) of South Africa in 1978 to that in 1979?
Ensure brevity in your answer.  0.88. What is the ratio of the Imports(as % of merchandise exports) in Haiti in 1978 to that in 1981?
Keep it short and to the point. 2.07. What is the ratio of the Imports(as % of merchandise exports) in Liberia in 1978 to that in 1981?
Offer a terse response. 0.77. What is the ratio of the Imports(as % of merchandise exports) of Somalia in 1978 to that in 1981?
Make the answer very short. 0.61. What is the ratio of the Imports(as % of merchandise exports) in South Africa in 1978 to that in 1981?
Ensure brevity in your answer.  1.56. What is the ratio of the Imports(as % of merchandise exports) in Haiti in 1979 to that in 1981?
Your answer should be very brief. 1.39. What is the ratio of the Imports(as % of merchandise exports) in Liberia in 1979 to that in 1981?
Offer a terse response. 0.86. What is the ratio of the Imports(as % of merchandise exports) of Somalia in 1979 to that in 1981?
Ensure brevity in your answer.  1.13. What is the ratio of the Imports(as % of merchandise exports) of South Africa in 1979 to that in 1981?
Offer a very short reply. 1.77. What is the difference between the highest and the second highest Imports(as % of merchandise exports) in Haiti?
Provide a short and direct response. 0.29. What is the difference between the highest and the second highest Imports(as % of merchandise exports) of Liberia?
Provide a succinct answer. 0.22. What is the difference between the highest and the second highest Imports(as % of merchandise exports) in Somalia?
Offer a very short reply. 0.83. What is the difference between the highest and the second highest Imports(as % of merchandise exports) of South Africa?
Ensure brevity in your answer.  0.49. What is the difference between the highest and the lowest Imports(as % of merchandise exports) in Haiti?
Make the answer very short. 2. What is the difference between the highest and the lowest Imports(as % of merchandise exports) in Liberia?
Your response must be concise. 0.47. What is the difference between the highest and the lowest Imports(as % of merchandise exports) in Somalia?
Offer a terse response. 4.24. What is the difference between the highest and the lowest Imports(as % of merchandise exports) of South Africa?
Offer a terse response. 2.18. 